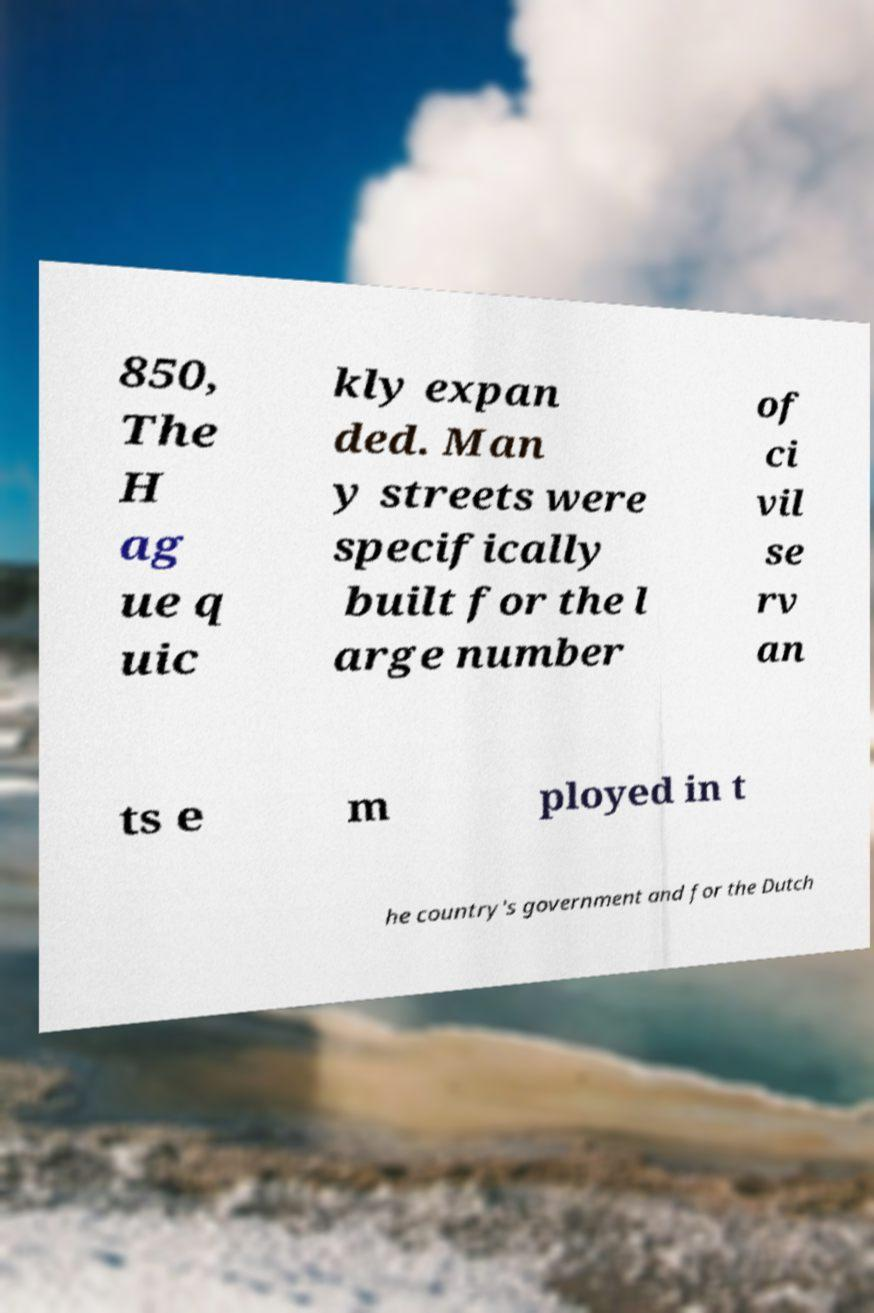Can you read and provide the text displayed in the image?This photo seems to have some interesting text. Can you extract and type it out for me? 850, The H ag ue q uic kly expan ded. Man y streets were specifically built for the l arge number of ci vil se rv an ts e m ployed in t he country's government and for the Dutch 